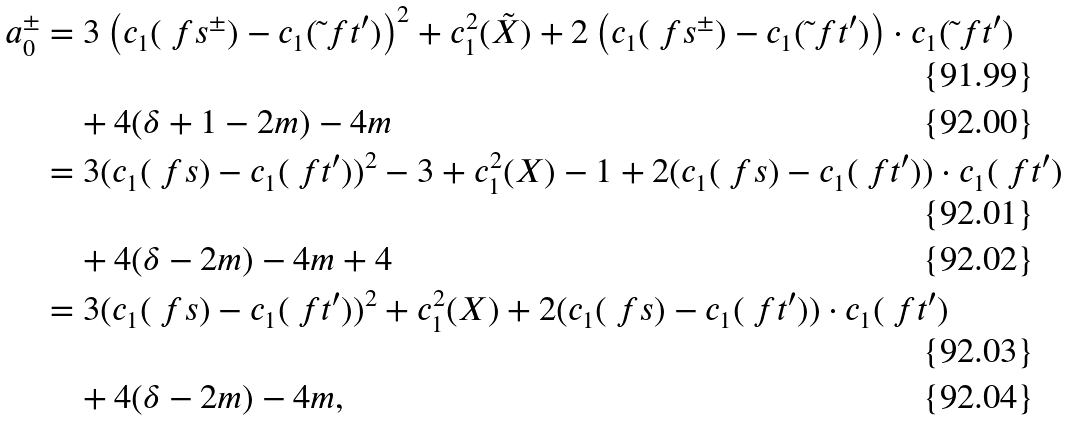<formula> <loc_0><loc_0><loc_500><loc_500>a _ { 0 } ^ { \pm } & = 3 \left ( c _ { 1 } ( \ f s ^ { \pm } ) - c _ { 1 } ( \tilde { \ } f t ^ { \prime } ) \right ) ^ { 2 } + c _ { 1 } ^ { 2 } ( \tilde { X } ) + 2 \left ( c _ { 1 } ( \ f s ^ { \pm } ) - c _ { 1 } ( \tilde { \ } f t ^ { \prime } ) \right ) \cdot c _ { 1 } ( \tilde { \ } f t ^ { \prime } ) \\ & \quad + 4 ( \delta + 1 - 2 m ) - 4 m \\ & = 3 ( c _ { 1 } ( \ f s ) - c _ { 1 } ( \ f t ^ { \prime } ) ) ^ { 2 } - 3 + c _ { 1 } ^ { 2 } ( X ) - 1 + 2 ( c _ { 1 } ( \ f s ) - c _ { 1 } ( \ f t ^ { \prime } ) ) \cdot c _ { 1 } ( \ f t ^ { \prime } ) \\ & \quad + 4 ( \delta - 2 m ) - 4 m + 4 \\ & = 3 ( c _ { 1 } ( \ f s ) - c _ { 1 } ( \ f t ^ { \prime } ) ) ^ { 2 } + c _ { 1 } ^ { 2 } ( X ) + 2 ( c _ { 1 } ( \ f s ) - c _ { 1 } ( \ f t ^ { \prime } ) ) \cdot c _ { 1 } ( \ f t ^ { \prime } ) \\ & \quad + 4 ( \delta - 2 m ) - 4 m ,</formula> 